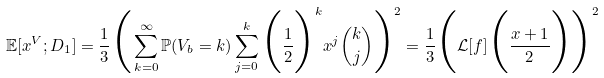<formula> <loc_0><loc_0><loc_500><loc_500>\mathbb { E } [ x ^ { V } ; D _ { 1 } ] = \frac { 1 } { 3 } \Big { ( } \sum _ { k = 0 } ^ { \infty } \mathbb { P } ( V _ { b } = k ) \sum _ { j = 0 } ^ { k } \Big { ( } \frac { 1 } { 2 } \Big { ) } ^ { k } x ^ { j } \binom { k } { j } \Big { ) } ^ { 2 } = \frac { 1 } { 3 } \Big { ( } \mathcal { L } [ f ] \Big { ( } \frac { x + 1 } { 2 } \Big { ) } \Big { ) } ^ { 2 }</formula> 